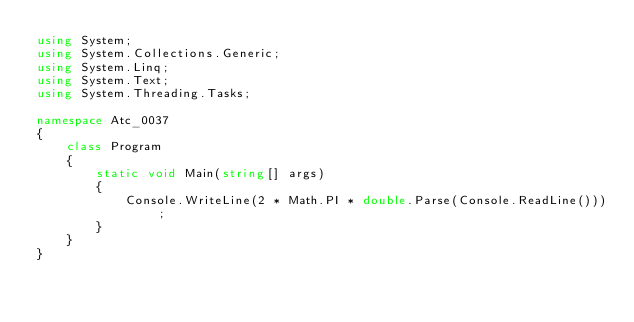Convert code to text. <code><loc_0><loc_0><loc_500><loc_500><_C#_>using System;
using System.Collections.Generic;
using System.Linq;
using System.Text;
using System.Threading.Tasks;

namespace Atc_0037
{
    class Program
    {
        static void Main(string[] args)
        {
            Console.WriteLine(2 * Math.PI * double.Parse(Console.ReadLine()));
        }
    }
}
</code> 